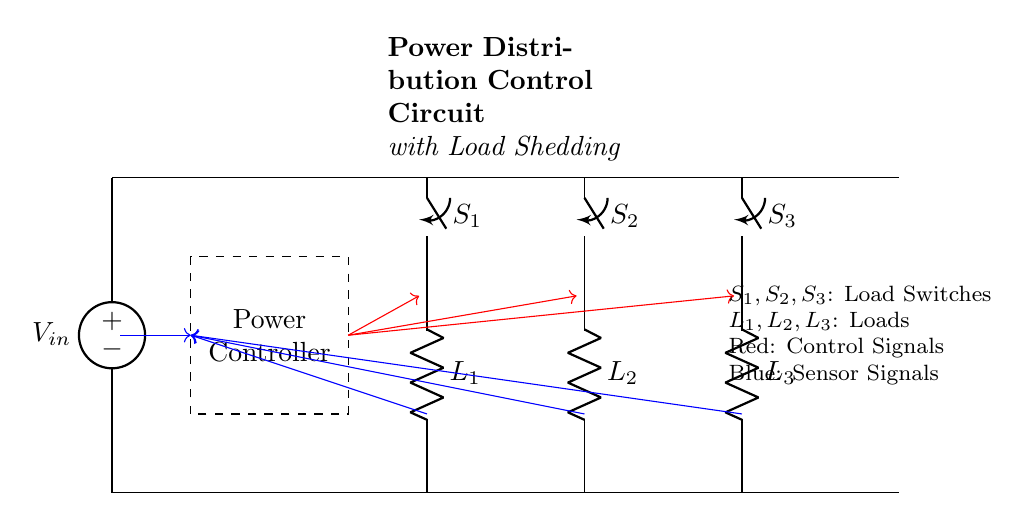What is the main purpose of this circuit? The main purpose of this circuit is to manage power distribution and enable load shedding for energy management. The presence of a power controller and load switches indicates that it can dynamically respond to changes in load demands.
Answer: Power management What are the loads labeled in the circuit? The loads in the circuit are labeled as L1, L2, and L3. They are defined as resistive loads connected to the bus, and each switch controls the corresponding load.
Answer: L1, L2, L3 How many load switches are in this circuit? The circuit includes three load switches, which are indicated as S1, S2, and S3. Each switch is represented in the diagram and controls a different load.
Answer: Three What type of signals are indicated in red in the circuit? The red signals represent control signals that originate from the power controller. This signifies that these signals are used to manage the operation of the load switches based on operational needs.
Answer: Control signals What does the blue signal represent in this circuit? The blue signals indicate sensor signals that provide feedback on the loads or system parameters back to the power controller. These signals are crucial for making informed decisions regarding load shedding.
Answer: Sensor signals What does the dashed rectangle in the circuit represent? The dashed rectangle represents the power controller, which is responsible for managing the load and ensuring efficient energy distribution. It handles decision-making based on the inputs it receives from sensor signals.
Answer: Power controller How are the loads connected to the main bus? The loads are connected in parallel to the main bus, allowing them to operate independently while still receiving power from the same source. Each load has a separate switch for control.
Answer: Parallel connection 